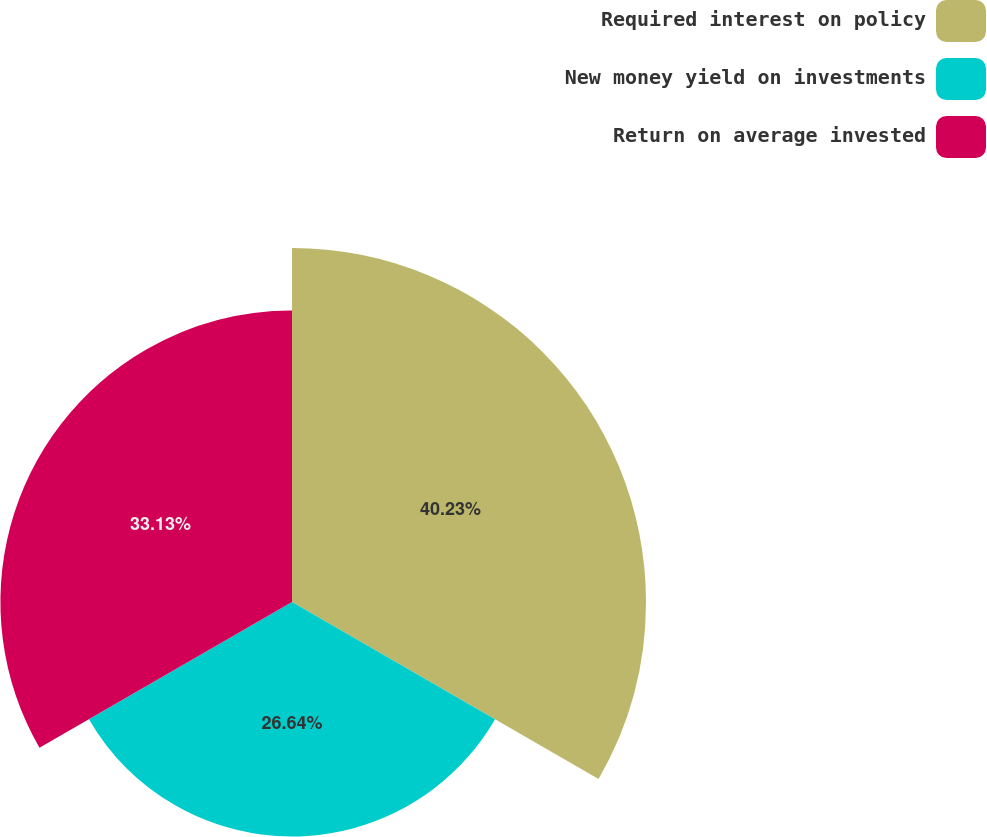<chart> <loc_0><loc_0><loc_500><loc_500><pie_chart><fcel>Required interest on policy<fcel>New money yield on investments<fcel>Return on average invested<nl><fcel>40.22%<fcel>26.64%<fcel>33.13%<nl></chart> 